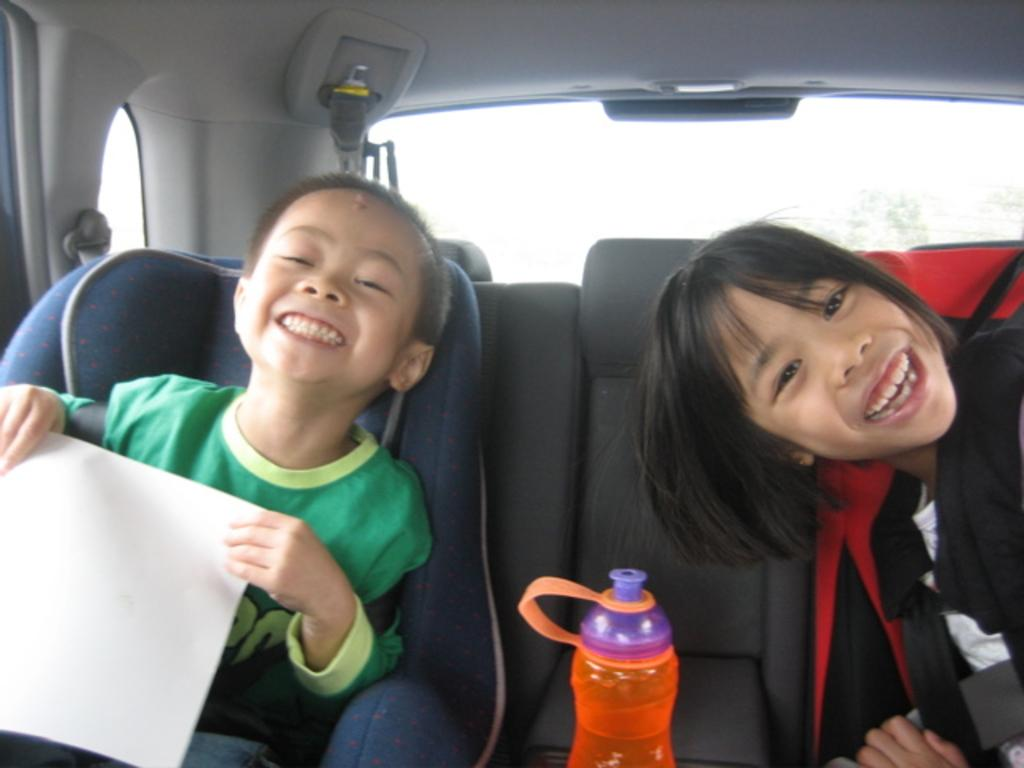How many people are present in the image? There are two people in the image. What are the two people doing in the image? The two people are sitting in a car. Can you describe any objects visible in the image? Yes, there is a bottle in the image. What type of screw is being used to hold the wrist in the image? There is no screw or wrist present in the image; it features two people sitting in a car and a bottle. 